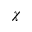Convert formula to latex. <formula><loc_0><loc_0><loc_500><loc_500>\chi</formula> 